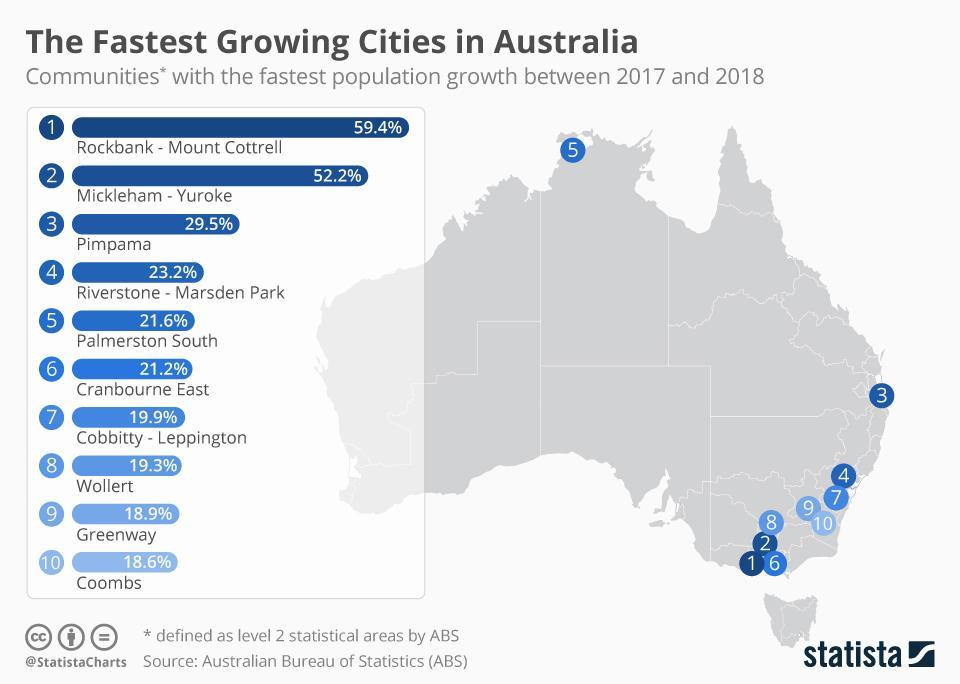After Mickleham-Yuroke, which is the next fastest growing city?
Answer the question with a short phrase. Pimpama By what percent is Riverstone-Marsden Park growing? 23.2% Which is the farthest growing city compared to others? Palmerston South How many cities have growth above 50% 2 